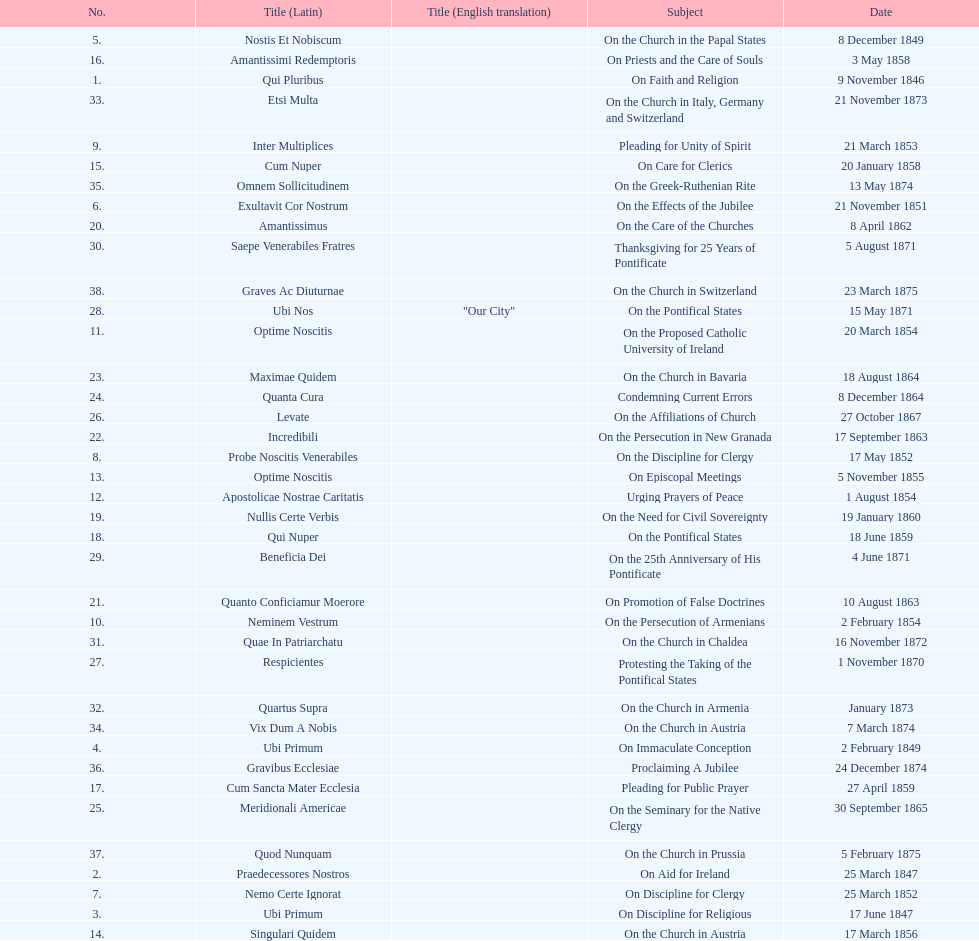In the first 10 years of his reign, how many encyclicals did pope pius ix issue? 14. 